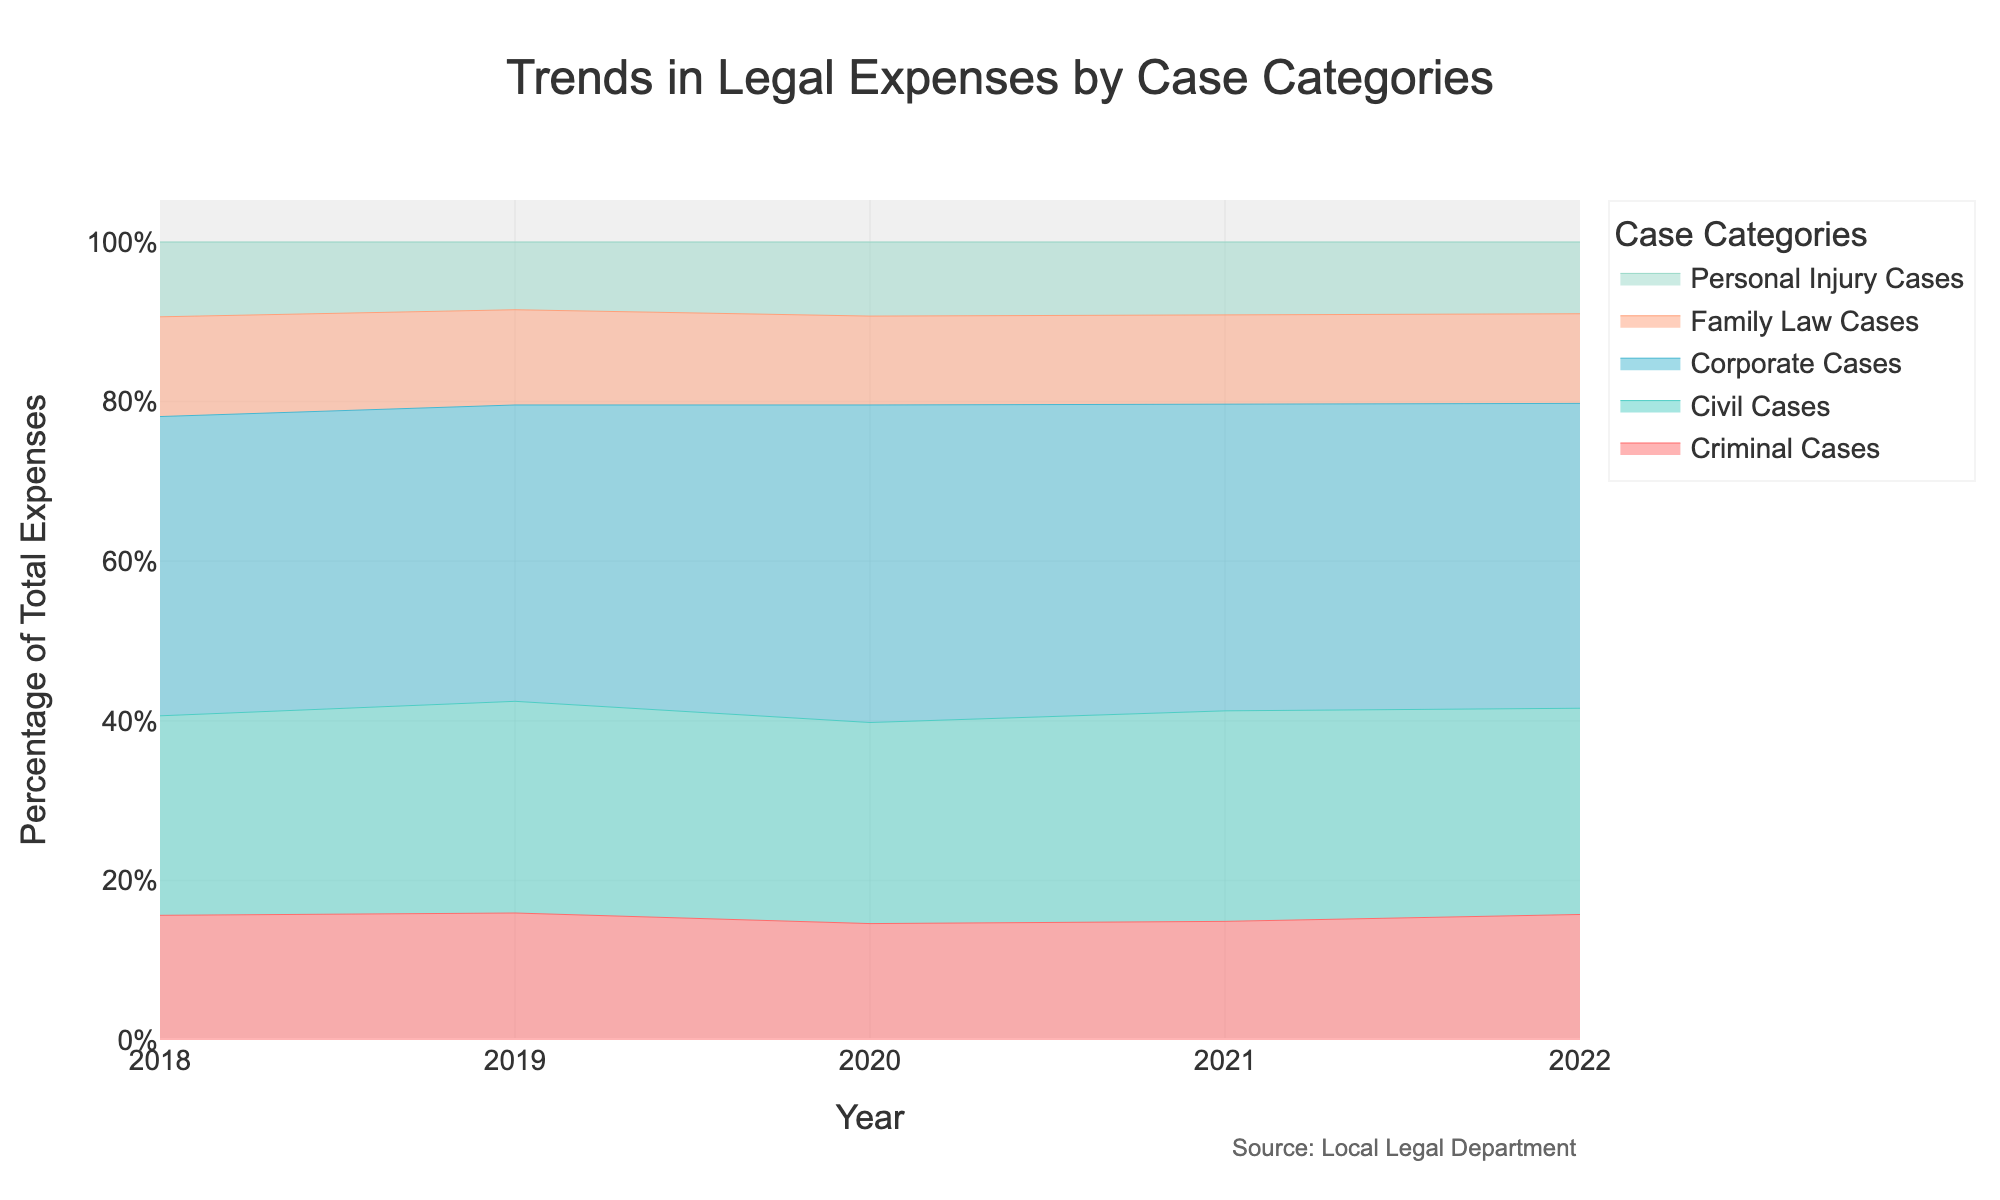What is the title of the area chart? The title is displayed prominently at the top of the chart. It helps to quickly understand the overall content and purpose of the chart.
Answer: Trends in Legal Expenses by Case Categories What is the general trend in the legal expenses for Family Law Cases from 2018 to 2022? To find the trend, follow the line representing Family Law Cases from 2018 to 2022 and observe if it is increasing, decreasing, or stable.
Answer: Increasing Which case category had the highest percentage of total expenses in 2022? Look at the top segment of the stacked area chart for the year 2022 to see the largest segment, which indicates the highest percentage.
Answer: Corporate Cases Which year experienced the smallest percentage of total expenses for Personal Injury Cases? Compare the segments representing Personal Injury Cases across all years and identify the year with the smallest segment.
Answer: 2018 How did the percentage of Corporate Cases expenses change from 2018 to 2022? Check the segment representing Corporate Cases at the start year (2018) and end year (2022) and note the change in size.
Answer: Increased By how many percentage points did the legal expenses for Criminal Cases change from 2019 to 2020? Look at the size of the segment for Criminal Cases in 2019 and 2020, calculate the percentage point change by subtracting the smaller value from the larger one.
Answer: Decreased by approximately 1 percentage point What was the approximate percentage of total expenses for Civil Cases in 2021? Locate the segment for Civil Cases in 2021 and use the y-axis to estimate its position within the total stacked area for that year.
Answer: Approximately 18% Did any case category's percentage of total expenses decrease consistently from 2018 to 2022? Analyze each case category's segment across the years to identify if any category consistently shrank over time.
Answer: No Which case category showed the most variability in its percentage of total expenses over the years? Track the relative size of each case category's segment year by year to identify the one that fluctuates the most.
Answer: Civil Cases 